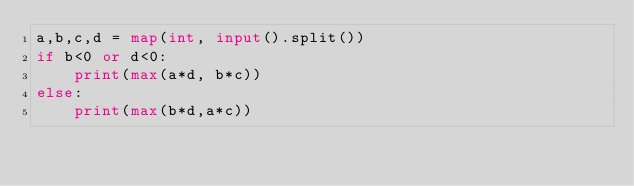<code> <loc_0><loc_0><loc_500><loc_500><_Python_>a,b,c,d = map(int, input().split())
if b<0 or d<0:
    print(max(a*d, b*c))
else:
    print(max(b*d,a*c))</code> 